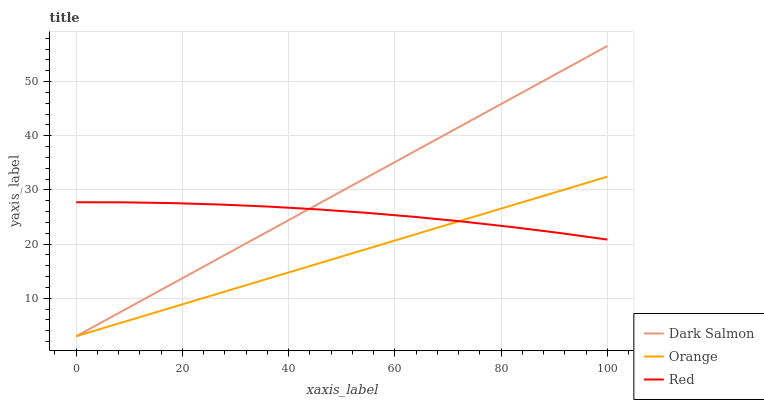Does Orange have the minimum area under the curve?
Answer yes or no. Yes. Does Dark Salmon have the maximum area under the curve?
Answer yes or no. Yes. Does Red have the minimum area under the curve?
Answer yes or no. No. Does Red have the maximum area under the curve?
Answer yes or no. No. Is Dark Salmon the smoothest?
Answer yes or no. Yes. Is Red the roughest?
Answer yes or no. Yes. Is Red the smoothest?
Answer yes or no. No. Is Dark Salmon the roughest?
Answer yes or no. No. Does Orange have the lowest value?
Answer yes or no. Yes. Does Red have the lowest value?
Answer yes or no. No. Does Dark Salmon have the highest value?
Answer yes or no. Yes. Does Red have the highest value?
Answer yes or no. No. Does Red intersect Orange?
Answer yes or no. Yes. Is Red less than Orange?
Answer yes or no. No. Is Red greater than Orange?
Answer yes or no. No. 